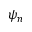<formula> <loc_0><loc_0><loc_500><loc_500>\psi _ { n }</formula> 